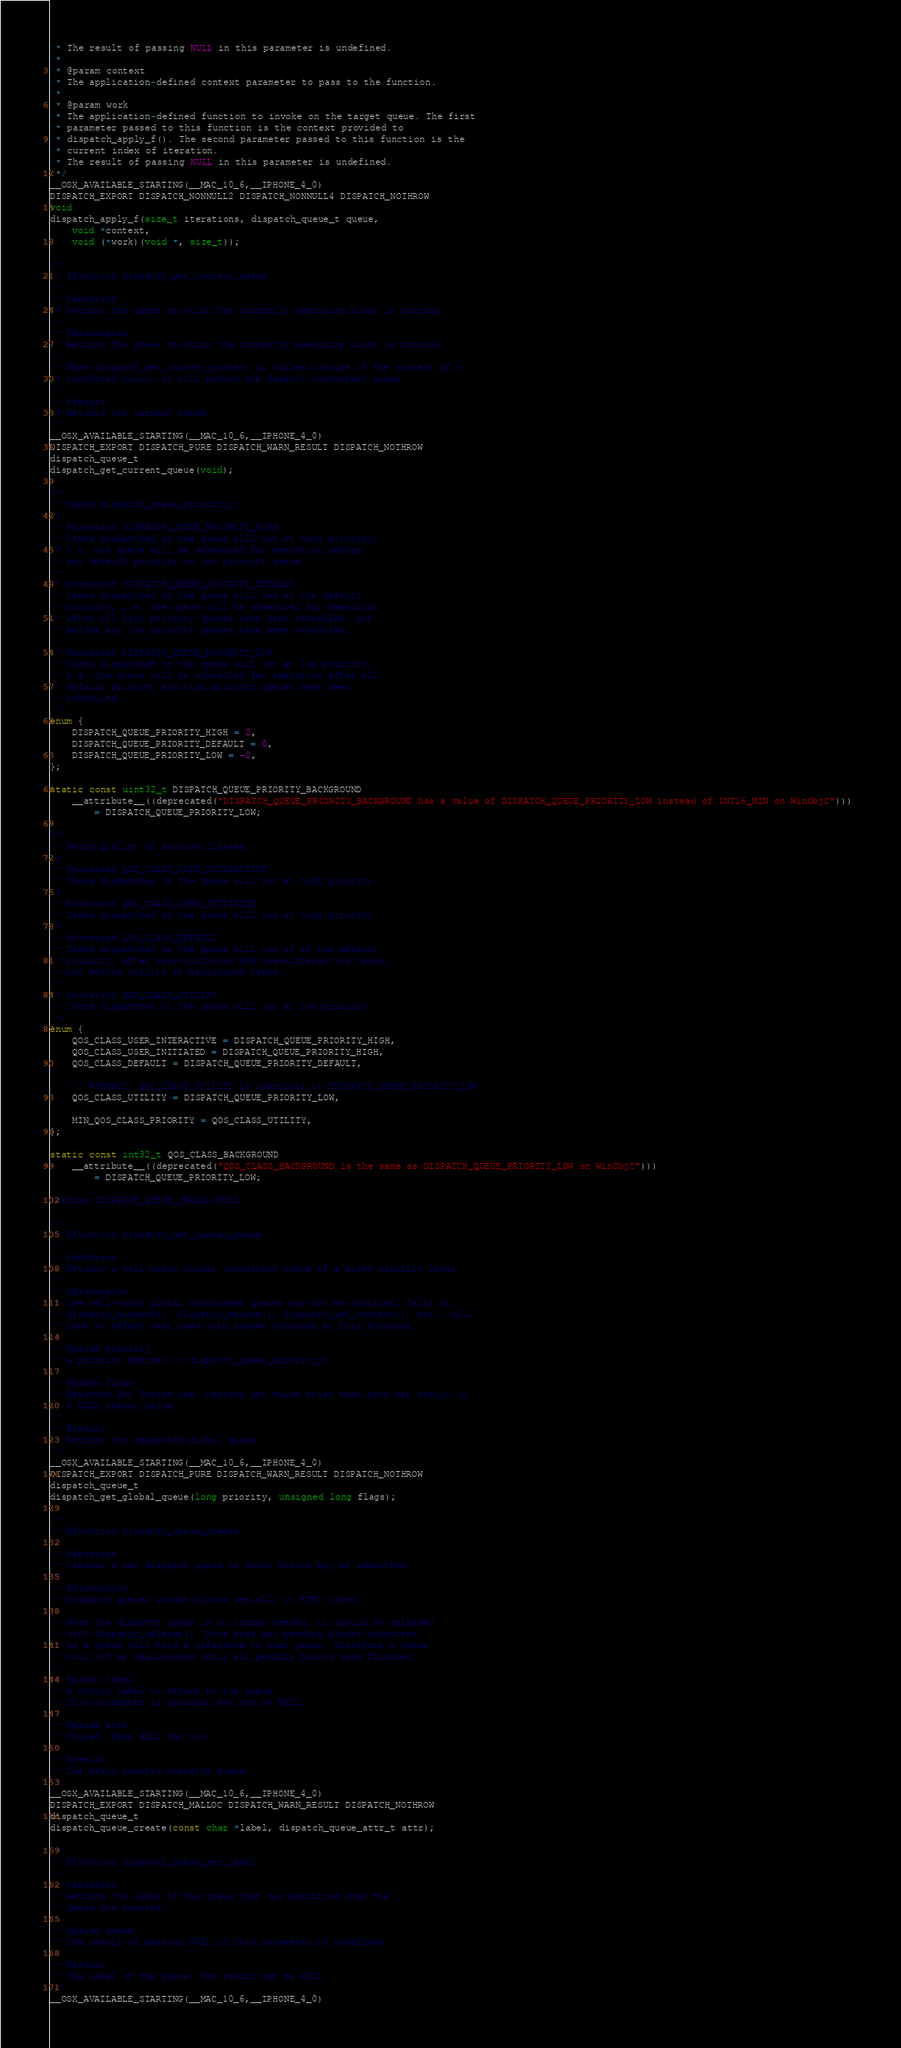<code> <loc_0><loc_0><loc_500><loc_500><_C_> * The result of passing NULL in this parameter is undefined.
 *
 * @param context
 * The application-defined context parameter to pass to the function.
 *
 * @param work
 * The application-defined function to invoke on the target queue. The first
 * parameter passed to this function is the context provided to
 * dispatch_apply_f(). The second parameter passed to this function is the
 * current index of iteration.
 * The result of passing NULL in this parameter is undefined.
 */
__OSX_AVAILABLE_STARTING(__MAC_10_6,__IPHONE_4_0)
DISPATCH_EXPORT DISPATCH_NONNULL2 DISPATCH_NONNULL4 DISPATCH_NOTHROW
void
dispatch_apply_f(size_t iterations, dispatch_queue_t queue,
	void *context,
	void (*work)(void *, size_t));

/*!
 * @function dispatch_get_current_queue
 *
 * @abstract
 * Returns the queue on which the currently executing block is running.
 * 
 * @discussion
 * Returns the queue on which the currently executing block is running.
 *
 * When dispatch_get_current_queue() is called outside of the context of a
 * submitted block, it will return the default concurrent queue.
 *
 * @result
 * Returns the current queue.
 */
__OSX_AVAILABLE_STARTING(__MAC_10_6,__IPHONE_4_0)
DISPATCH_EXPORT DISPATCH_PURE DISPATCH_WARN_RESULT DISPATCH_NOTHROW
dispatch_queue_t
dispatch_get_current_queue(void);

/*!
 * @enum dispatch_queue_priority_t
 *
 * @constant DISPATCH_QUEUE_PRIORITY_HIGH
 * Items dispatched to the queue will run at high priority,
 * i.e. the queue will be scheduled for execution before
 * any default priority or low priority queue.
 *
 * @constant DISPATCH_QUEUE_PRIORITY_DEFAULT
 * Items dispatched to the queue will run at the default
 * priority, i.e. the queue will be scheduled for execution
 * after all high priority queues have been scheduled, but
 * before any low priority queues have been scheduled.
 *
 * @constant DISPATCH_QUEUE_PRIORITY_LOW
 * Items dispatched to the queue will run at low priority,
 * i.e. the queue will be scheduled for execution after all
 * default priority and high priority queues have been
 * scheduled.
 */
enum {
	DISPATCH_QUEUE_PRIORITY_HIGH = 2,
	DISPATCH_QUEUE_PRIORITY_DEFAULT = 0,
	DISPATCH_QUEUE_PRIORITY_LOW = -2,
};

static const uint32_t DISPATCH_QUEUE_PRIORITY_BACKGROUND 
    __attribute__((deprecated("DISPATCH_QUEUE_PRIORITY_BACKGROUND has a value of DISPATCH_QUEUE_PRIORITY_LOW instead of INT16_MIN on WinObjC"))) 
        = DISPATCH_QUEUE_PRIORITY_LOW;

/*!
 * @enum Quality of service classes
 *
 * @constant QOS_CLASS_USER_INTERACTIVE
 * Items dispatched to the queue will run at high priority.
 *
 * @constant QOS_CLASS_USER_INITIATED
 * Items dispatched to the queue will run at high priority.
 *
 * @constant QOS_CLASS_DEFAULT
 * Items dispatched to the queue will run at at the default
 * priority, after user-initiated and user-interactive tasks,
 * but before utility or background tasks.
 *
 * @constant QOS_CLASS_UTILITY
 * Items dispatched to the queue will run at low priority.
 */
enum {
	QOS_CLASS_USER_INTERACTIVE = DISPATCH_QUEUE_PRIORITY_HIGH,
	QOS_CLASS_USER_INITIATED = DISPATCH_QUEUE_PRIORITY_HIGH,
	QOS_CLASS_DEFAULT = DISPATCH_QUEUE_PRIORITY_DEFAULT,

	// WINOBJC: QOS_CLASS_UTILITY is identical to DISPATCH_QUEUE_PRIORITY_LOW
	QOS_CLASS_UTILITY = DISPATCH_QUEUE_PRIORITY_LOW,

	MIN_QOS_CLASS_PRIORITY = QOS_CLASS_UTILITY,
};

static const int32_t QOS_CLASS_BACKGROUND
    __attribute__((deprecated("QOS_CLASS_BACKGROUND is the same as DISPATCH_QUEUE_PRIORITY_LOW on WinObjC")))
        = DISPATCH_QUEUE_PRIORITY_LOW;
        
#define DISPATCH_QUEUE_SERIAL NULL

/*!
 * @function dispatch_get_global_queue
 *
 * @abstract
 * Returns a well-known global concurrent queue of a given priority level.
 *
 * @discussion
 * The well-known global concurrent queues may not be modified. Calls to
 * dispatch_suspend(), dispatch_resume(), dispatch_set_context(), etc., will
 * have no effect when used with queues returned by this function.
 *
 * @param priority
 * A priority defined in dispatch_queue_priority_t
 *
 * @param flags
 * Reserved for future use. Passing any value other than zero may result in
 * a NULL return value.
 *
 * @result
 * Returns the requested global queue.
 */
__OSX_AVAILABLE_STARTING(__MAC_10_6,__IPHONE_4_0)
DISPATCH_EXPORT DISPATCH_PURE DISPATCH_WARN_RESULT DISPATCH_NOTHROW
dispatch_queue_t
dispatch_get_global_queue(long priority, unsigned long flags);

/*!
 * @function dispatch_queue_create
 *
 * @abstract
 * Creates a new dispatch queue to which blocks may be submitted.
 *
 * @discussion
 * Dispatch queues invoke blocks serially in FIFO order.
 *
 * When the dispatch queue is no longer needed, it should be released
 * with dispatch_release(). Note that any pending blocks submitted
 * to a queue will hold a reference to that queue. Therefore a queue
 * will not be deallocated until all pending blocks have finished.
 *
 * @param label
 * A string label to attach to the queue.
 * This parameter is optional and may be NULL.
 *
 * @param attr
 * Unused. Pass NULL for now.
 *
 * @result
 * The newly created dispatch queue.
 */
__OSX_AVAILABLE_STARTING(__MAC_10_6,__IPHONE_4_0)
DISPATCH_EXPORT DISPATCH_MALLOC DISPATCH_WARN_RESULT DISPATCH_NOTHROW
dispatch_queue_t
dispatch_queue_create(const char *label, dispatch_queue_attr_t attr);

/*!
 * @function dispatch_queue_get_label
 *
 * @abstract
 * Returns the label of the queue that was specified when the
 * queue was created.
 *
 * @param queue
 * The result of passing NULL in this parameter is undefined.
 *
 * @result
 * The label of the queue. The result may be NULL.
 */
__OSX_AVAILABLE_STARTING(__MAC_10_6,__IPHONE_4_0)</code> 